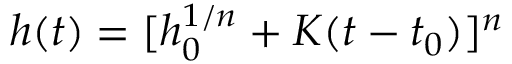<formula> <loc_0><loc_0><loc_500><loc_500>h ( t ) = [ h _ { 0 } ^ { 1 / n } + K ( t - t _ { 0 } ) ] ^ { n }</formula> 